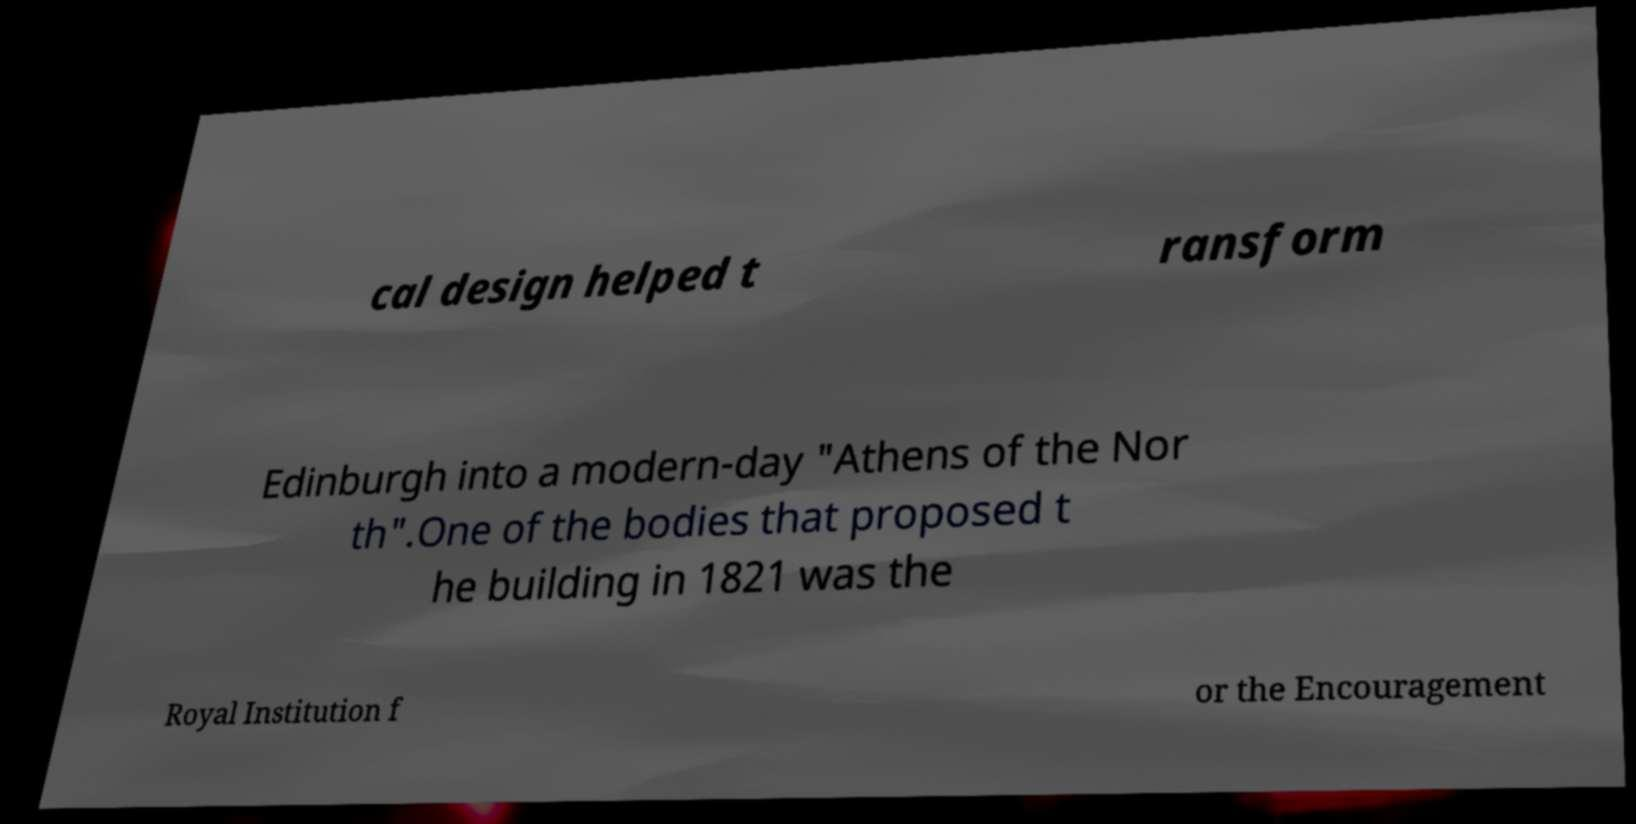Please identify and transcribe the text found in this image. cal design helped t ransform Edinburgh into a modern-day "Athens of the Nor th".One of the bodies that proposed t he building in 1821 was the Royal Institution f or the Encouragement 